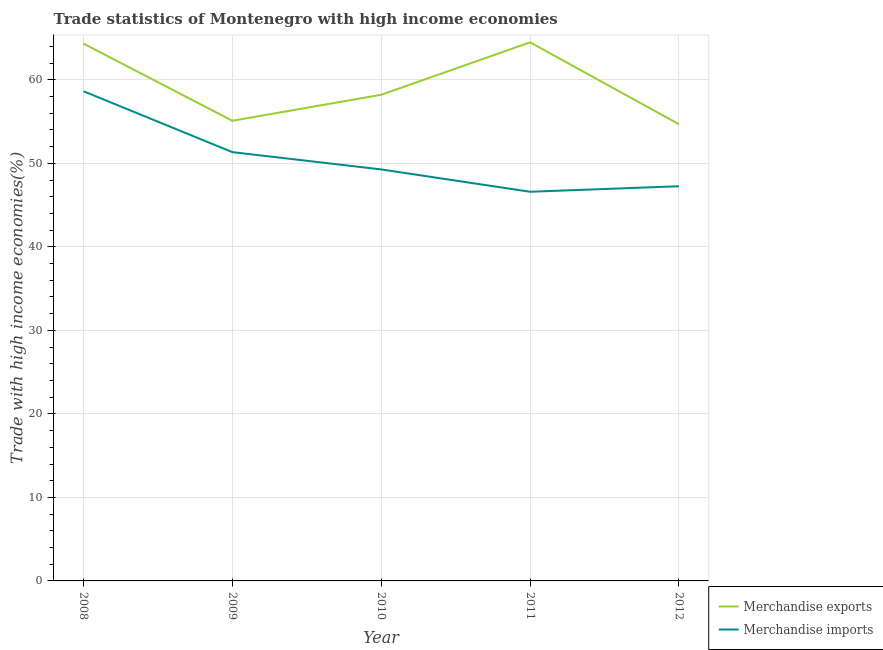How many different coloured lines are there?
Your answer should be compact. 2. What is the merchandise exports in 2009?
Give a very brief answer. 55.1. Across all years, what is the maximum merchandise exports?
Make the answer very short. 64.49. Across all years, what is the minimum merchandise exports?
Your answer should be very brief. 54.69. In which year was the merchandise imports maximum?
Provide a short and direct response. 2008. What is the total merchandise imports in the graph?
Offer a very short reply. 253.13. What is the difference between the merchandise exports in 2009 and that in 2010?
Ensure brevity in your answer.  -3.12. What is the difference between the merchandise imports in 2010 and the merchandise exports in 2009?
Make the answer very short. -5.83. What is the average merchandise exports per year?
Provide a succinct answer. 59.37. In the year 2008, what is the difference between the merchandise exports and merchandise imports?
Your answer should be very brief. 5.7. In how many years, is the merchandise exports greater than 56 %?
Offer a very short reply. 3. What is the ratio of the merchandise imports in 2010 to that in 2012?
Your answer should be very brief. 1.04. Is the difference between the merchandise exports in 2011 and 2012 greater than the difference between the merchandise imports in 2011 and 2012?
Keep it short and to the point. Yes. What is the difference between the highest and the second highest merchandise exports?
Provide a short and direct response. 0.15. What is the difference between the highest and the lowest merchandise imports?
Your answer should be very brief. 12.04. In how many years, is the merchandise exports greater than the average merchandise exports taken over all years?
Keep it short and to the point. 2. Is the sum of the merchandise imports in 2008 and 2012 greater than the maximum merchandise exports across all years?
Offer a terse response. Yes. Is the merchandise exports strictly greater than the merchandise imports over the years?
Offer a terse response. Yes. Is the merchandise imports strictly less than the merchandise exports over the years?
Offer a very short reply. Yes. How many lines are there?
Make the answer very short. 2. How many years are there in the graph?
Provide a short and direct response. 5. Are the values on the major ticks of Y-axis written in scientific E-notation?
Your answer should be very brief. No. Does the graph contain any zero values?
Keep it short and to the point. No. Does the graph contain grids?
Offer a terse response. Yes. Where does the legend appear in the graph?
Give a very brief answer. Bottom right. What is the title of the graph?
Provide a succinct answer. Trade statistics of Montenegro with high income economies. What is the label or title of the X-axis?
Ensure brevity in your answer.  Year. What is the label or title of the Y-axis?
Provide a succinct answer. Trade with high income economies(%). What is the Trade with high income economies(%) of Merchandise exports in 2008?
Ensure brevity in your answer.  64.34. What is the Trade with high income economies(%) of Merchandise imports in 2008?
Provide a short and direct response. 58.64. What is the Trade with high income economies(%) of Merchandise exports in 2009?
Offer a very short reply. 55.1. What is the Trade with high income economies(%) of Merchandise imports in 2009?
Keep it short and to the point. 51.35. What is the Trade with high income economies(%) in Merchandise exports in 2010?
Offer a very short reply. 58.22. What is the Trade with high income economies(%) in Merchandise imports in 2010?
Offer a very short reply. 49.28. What is the Trade with high income economies(%) in Merchandise exports in 2011?
Your response must be concise. 64.49. What is the Trade with high income economies(%) of Merchandise imports in 2011?
Offer a terse response. 46.6. What is the Trade with high income economies(%) in Merchandise exports in 2012?
Offer a terse response. 54.69. What is the Trade with high income economies(%) in Merchandise imports in 2012?
Make the answer very short. 47.27. Across all years, what is the maximum Trade with high income economies(%) in Merchandise exports?
Provide a succinct answer. 64.49. Across all years, what is the maximum Trade with high income economies(%) of Merchandise imports?
Your answer should be compact. 58.64. Across all years, what is the minimum Trade with high income economies(%) of Merchandise exports?
Keep it short and to the point. 54.69. Across all years, what is the minimum Trade with high income economies(%) in Merchandise imports?
Your answer should be very brief. 46.6. What is the total Trade with high income economies(%) in Merchandise exports in the graph?
Provide a succinct answer. 296.85. What is the total Trade with high income economies(%) in Merchandise imports in the graph?
Your answer should be very brief. 253.13. What is the difference between the Trade with high income economies(%) in Merchandise exports in 2008 and that in 2009?
Offer a very short reply. 9.24. What is the difference between the Trade with high income economies(%) of Merchandise imports in 2008 and that in 2009?
Your answer should be compact. 7.29. What is the difference between the Trade with high income economies(%) of Merchandise exports in 2008 and that in 2010?
Your answer should be compact. 6.12. What is the difference between the Trade with high income economies(%) of Merchandise imports in 2008 and that in 2010?
Your answer should be very brief. 9.36. What is the difference between the Trade with high income economies(%) in Merchandise exports in 2008 and that in 2011?
Ensure brevity in your answer.  -0.15. What is the difference between the Trade with high income economies(%) in Merchandise imports in 2008 and that in 2011?
Offer a very short reply. 12.04. What is the difference between the Trade with high income economies(%) in Merchandise exports in 2008 and that in 2012?
Provide a short and direct response. 9.65. What is the difference between the Trade with high income economies(%) in Merchandise imports in 2008 and that in 2012?
Provide a short and direct response. 11.37. What is the difference between the Trade with high income economies(%) in Merchandise exports in 2009 and that in 2010?
Make the answer very short. -3.12. What is the difference between the Trade with high income economies(%) of Merchandise imports in 2009 and that in 2010?
Give a very brief answer. 2.07. What is the difference between the Trade with high income economies(%) of Merchandise exports in 2009 and that in 2011?
Your answer should be compact. -9.39. What is the difference between the Trade with high income economies(%) in Merchandise imports in 2009 and that in 2011?
Your answer should be very brief. 4.75. What is the difference between the Trade with high income economies(%) of Merchandise exports in 2009 and that in 2012?
Offer a terse response. 0.41. What is the difference between the Trade with high income economies(%) in Merchandise imports in 2009 and that in 2012?
Provide a short and direct response. 4.08. What is the difference between the Trade with high income economies(%) in Merchandise exports in 2010 and that in 2011?
Give a very brief answer. -6.28. What is the difference between the Trade with high income economies(%) in Merchandise imports in 2010 and that in 2011?
Provide a short and direct response. 2.67. What is the difference between the Trade with high income economies(%) of Merchandise exports in 2010 and that in 2012?
Offer a terse response. 3.53. What is the difference between the Trade with high income economies(%) in Merchandise imports in 2010 and that in 2012?
Your answer should be very brief. 2.01. What is the difference between the Trade with high income economies(%) of Merchandise exports in 2011 and that in 2012?
Ensure brevity in your answer.  9.81. What is the difference between the Trade with high income economies(%) in Merchandise imports in 2011 and that in 2012?
Keep it short and to the point. -0.66. What is the difference between the Trade with high income economies(%) in Merchandise exports in 2008 and the Trade with high income economies(%) in Merchandise imports in 2009?
Offer a very short reply. 12.99. What is the difference between the Trade with high income economies(%) of Merchandise exports in 2008 and the Trade with high income economies(%) of Merchandise imports in 2010?
Keep it short and to the point. 15.07. What is the difference between the Trade with high income economies(%) in Merchandise exports in 2008 and the Trade with high income economies(%) in Merchandise imports in 2011?
Give a very brief answer. 17.74. What is the difference between the Trade with high income economies(%) of Merchandise exports in 2008 and the Trade with high income economies(%) of Merchandise imports in 2012?
Your answer should be very brief. 17.08. What is the difference between the Trade with high income economies(%) of Merchandise exports in 2009 and the Trade with high income economies(%) of Merchandise imports in 2010?
Make the answer very short. 5.83. What is the difference between the Trade with high income economies(%) in Merchandise exports in 2009 and the Trade with high income economies(%) in Merchandise imports in 2011?
Provide a short and direct response. 8.5. What is the difference between the Trade with high income economies(%) in Merchandise exports in 2009 and the Trade with high income economies(%) in Merchandise imports in 2012?
Make the answer very short. 7.84. What is the difference between the Trade with high income economies(%) in Merchandise exports in 2010 and the Trade with high income economies(%) in Merchandise imports in 2011?
Your answer should be very brief. 11.62. What is the difference between the Trade with high income economies(%) in Merchandise exports in 2010 and the Trade with high income economies(%) in Merchandise imports in 2012?
Give a very brief answer. 10.95. What is the difference between the Trade with high income economies(%) in Merchandise exports in 2011 and the Trade with high income economies(%) in Merchandise imports in 2012?
Ensure brevity in your answer.  17.23. What is the average Trade with high income economies(%) in Merchandise exports per year?
Ensure brevity in your answer.  59.37. What is the average Trade with high income economies(%) in Merchandise imports per year?
Your answer should be very brief. 50.63. In the year 2008, what is the difference between the Trade with high income economies(%) of Merchandise exports and Trade with high income economies(%) of Merchandise imports?
Give a very brief answer. 5.7. In the year 2009, what is the difference between the Trade with high income economies(%) in Merchandise exports and Trade with high income economies(%) in Merchandise imports?
Ensure brevity in your answer.  3.76. In the year 2010, what is the difference between the Trade with high income economies(%) of Merchandise exports and Trade with high income economies(%) of Merchandise imports?
Your response must be concise. 8.94. In the year 2011, what is the difference between the Trade with high income economies(%) in Merchandise exports and Trade with high income economies(%) in Merchandise imports?
Provide a succinct answer. 17.89. In the year 2012, what is the difference between the Trade with high income economies(%) in Merchandise exports and Trade with high income economies(%) in Merchandise imports?
Offer a very short reply. 7.42. What is the ratio of the Trade with high income economies(%) in Merchandise exports in 2008 to that in 2009?
Provide a succinct answer. 1.17. What is the ratio of the Trade with high income economies(%) in Merchandise imports in 2008 to that in 2009?
Ensure brevity in your answer.  1.14. What is the ratio of the Trade with high income economies(%) of Merchandise exports in 2008 to that in 2010?
Offer a very short reply. 1.11. What is the ratio of the Trade with high income economies(%) of Merchandise imports in 2008 to that in 2010?
Make the answer very short. 1.19. What is the ratio of the Trade with high income economies(%) of Merchandise imports in 2008 to that in 2011?
Your answer should be compact. 1.26. What is the ratio of the Trade with high income economies(%) in Merchandise exports in 2008 to that in 2012?
Offer a terse response. 1.18. What is the ratio of the Trade with high income economies(%) of Merchandise imports in 2008 to that in 2012?
Ensure brevity in your answer.  1.24. What is the ratio of the Trade with high income economies(%) in Merchandise exports in 2009 to that in 2010?
Your answer should be very brief. 0.95. What is the ratio of the Trade with high income economies(%) of Merchandise imports in 2009 to that in 2010?
Offer a very short reply. 1.04. What is the ratio of the Trade with high income economies(%) in Merchandise exports in 2009 to that in 2011?
Provide a short and direct response. 0.85. What is the ratio of the Trade with high income economies(%) of Merchandise imports in 2009 to that in 2011?
Provide a short and direct response. 1.1. What is the ratio of the Trade with high income economies(%) of Merchandise exports in 2009 to that in 2012?
Provide a short and direct response. 1.01. What is the ratio of the Trade with high income economies(%) in Merchandise imports in 2009 to that in 2012?
Keep it short and to the point. 1.09. What is the ratio of the Trade with high income economies(%) of Merchandise exports in 2010 to that in 2011?
Make the answer very short. 0.9. What is the ratio of the Trade with high income economies(%) in Merchandise imports in 2010 to that in 2011?
Give a very brief answer. 1.06. What is the ratio of the Trade with high income economies(%) in Merchandise exports in 2010 to that in 2012?
Offer a very short reply. 1.06. What is the ratio of the Trade with high income economies(%) in Merchandise imports in 2010 to that in 2012?
Keep it short and to the point. 1.04. What is the ratio of the Trade with high income economies(%) in Merchandise exports in 2011 to that in 2012?
Provide a succinct answer. 1.18. What is the difference between the highest and the second highest Trade with high income economies(%) in Merchandise exports?
Ensure brevity in your answer.  0.15. What is the difference between the highest and the second highest Trade with high income economies(%) in Merchandise imports?
Make the answer very short. 7.29. What is the difference between the highest and the lowest Trade with high income economies(%) in Merchandise exports?
Your response must be concise. 9.81. What is the difference between the highest and the lowest Trade with high income economies(%) in Merchandise imports?
Offer a terse response. 12.04. 